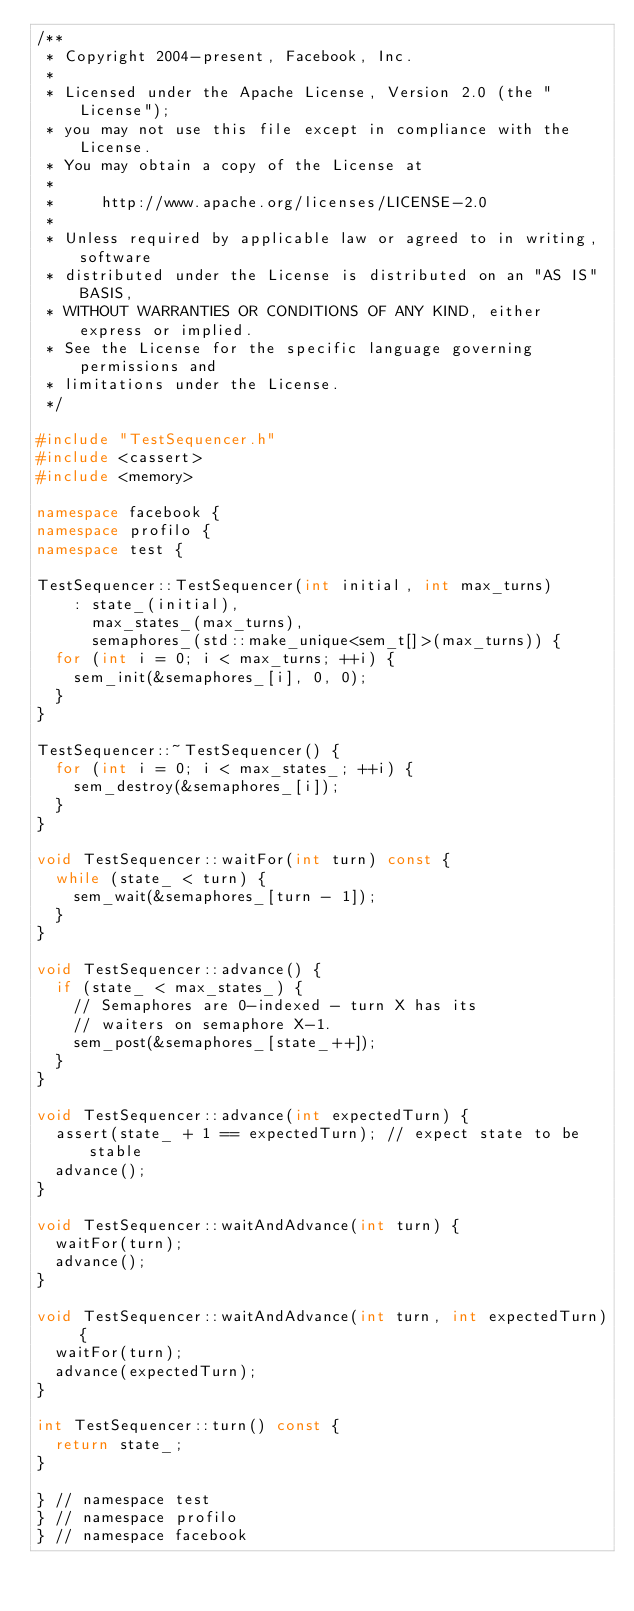<code> <loc_0><loc_0><loc_500><loc_500><_C++_>/**
 * Copyright 2004-present, Facebook, Inc.
 *
 * Licensed under the Apache License, Version 2.0 (the "License");
 * you may not use this file except in compliance with the License.
 * You may obtain a copy of the License at
 *
 *     http://www.apache.org/licenses/LICENSE-2.0
 *
 * Unless required by applicable law or agreed to in writing, software
 * distributed under the License is distributed on an "AS IS" BASIS,
 * WITHOUT WARRANTIES OR CONDITIONS OF ANY KIND, either express or implied.
 * See the License for the specific language governing permissions and
 * limitations under the License.
 */

#include "TestSequencer.h"
#include <cassert>
#include <memory>

namespace facebook {
namespace profilo {
namespace test {

TestSequencer::TestSequencer(int initial, int max_turns)
    : state_(initial),
      max_states_(max_turns),
      semaphores_(std::make_unique<sem_t[]>(max_turns)) {
  for (int i = 0; i < max_turns; ++i) {
    sem_init(&semaphores_[i], 0, 0);
  }
}

TestSequencer::~TestSequencer() {
  for (int i = 0; i < max_states_; ++i) {
    sem_destroy(&semaphores_[i]);
  }
}

void TestSequencer::waitFor(int turn) const {
  while (state_ < turn) {
    sem_wait(&semaphores_[turn - 1]);
  }
}

void TestSequencer::advance() {
  if (state_ < max_states_) {
    // Semaphores are 0-indexed - turn X has its
    // waiters on semaphore X-1.
    sem_post(&semaphores_[state_++]);
  }
}

void TestSequencer::advance(int expectedTurn) {
  assert(state_ + 1 == expectedTurn); // expect state to be stable
  advance();
}

void TestSequencer::waitAndAdvance(int turn) {
  waitFor(turn);
  advance();
}

void TestSequencer::waitAndAdvance(int turn, int expectedTurn) {
  waitFor(turn);
  advance(expectedTurn);
}

int TestSequencer::turn() const {
  return state_;
}

} // namespace test
} // namespace profilo
} // namespace facebook
</code> 